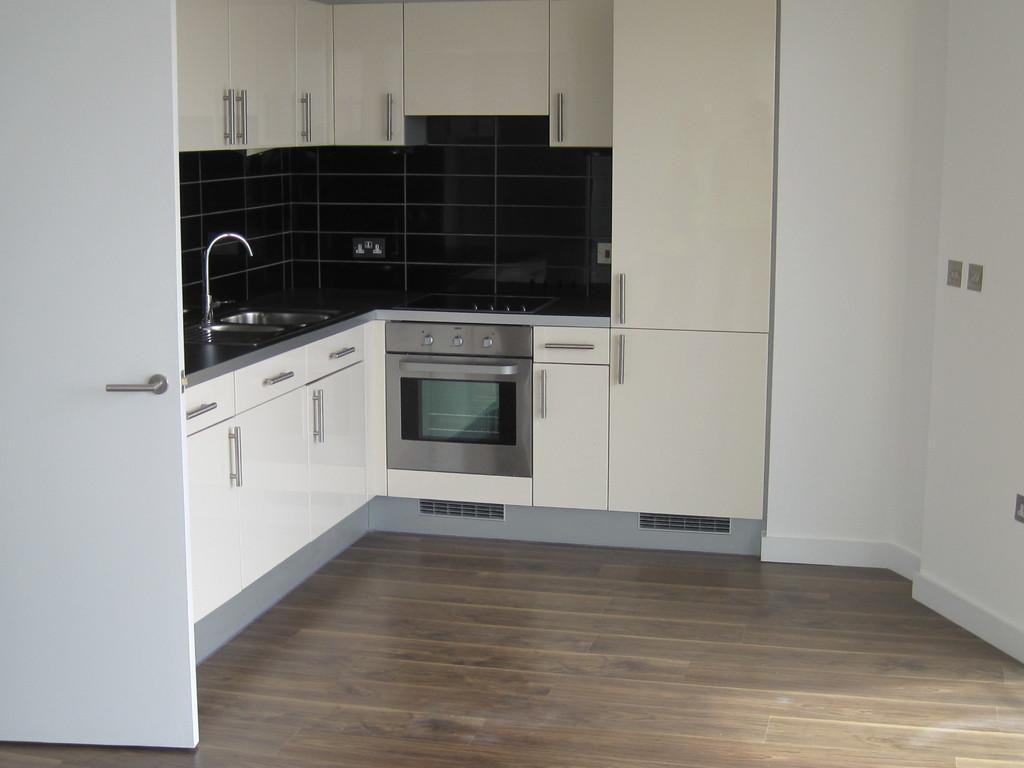Please provide a concise description of this image. There is a white door in the left corner and there is a wash basin beside it and there are few cupboards above and below it. 